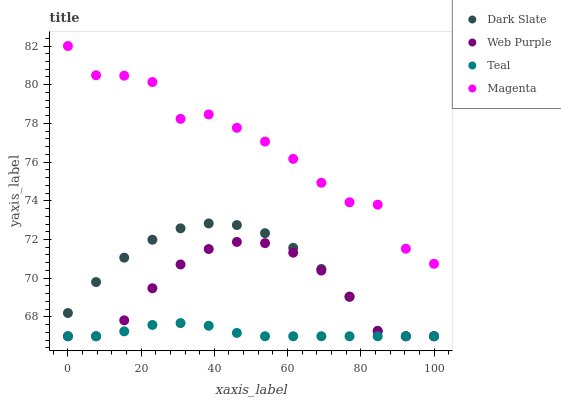Does Teal have the minimum area under the curve?
Answer yes or no. Yes. Does Magenta have the maximum area under the curve?
Answer yes or no. Yes. Does Web Purple have the minimum area under the curve?
Answer yes or no. No. Does Web Purple have the maximum area under the curve?
Answer yes or no. No. Is Teal the smoothest?
Answer yes or no. Yes. Is Magenta the roughest?
Answer yes or no. Yes. Is Web Purple the smoothest?
Answer yes or no. No. Is Web Purple the roughest?
Answer yes or no. No. Does Dark Slate have the lowest value?
Answer yes or no. Yes. Does Magenta have the lowest value?
Answer yes or no. No. Does Magenta have the highest value?
Answer yes or no. Yes. Does Web Purple have the highest value?
Answer yes or no. No. Is Web Purple less than Magenta?
Answer yes or no. Yes. Is Magenta greater than Dark Slate?
Answer yes or no. Yes. Does Teal intersect Dark Slate?
Answer yes or no. Yes. Is Teal less than Dark Slate?
Answer yes or no. No. Is Teal greater than Dark Slate?
Answer yes or no. No. Does Web Purple intersect Magenta?
Answer yes or no. No. 